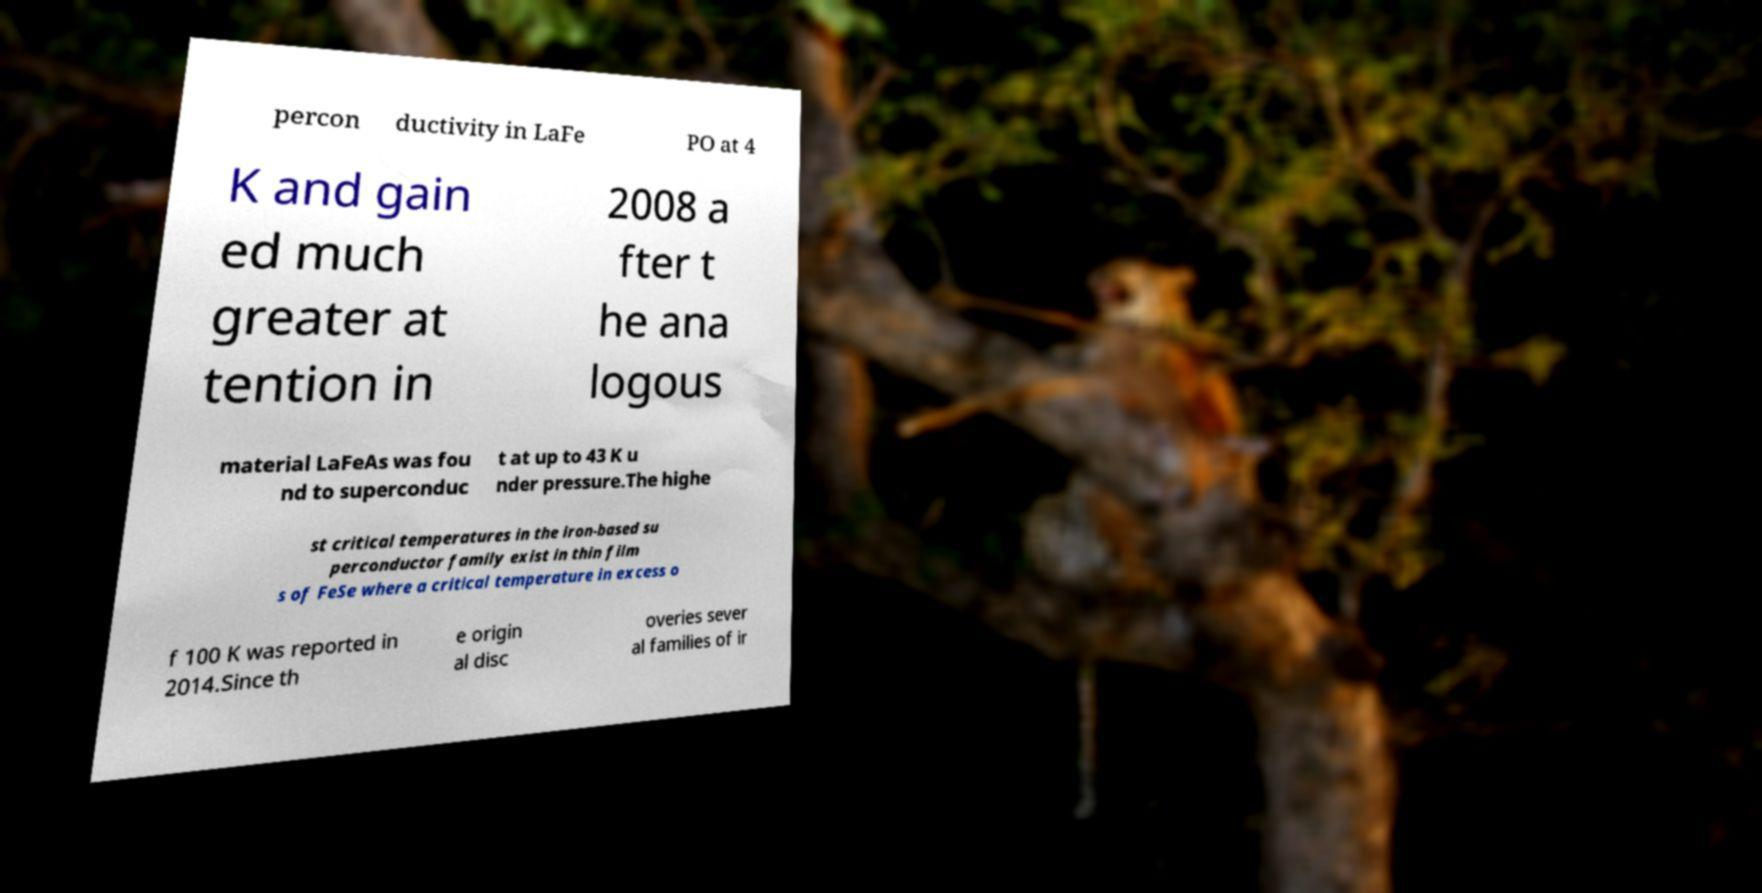Please read and relay the text visible in this image. What does it say? percon ductivity in LaFe PO at 4 K and gain ed much greater at tention in 2008 a fter t he ana logous material LaFeAs was fou nd to superconduc t at up to 43 K u nder pressure.The highe st critical temperatures in the iron-based su perconductor family exist in thin film s of FeSe where a critical temperature in excess o f 100 K was reported in 2014.Since th e origin al disc overies sever al families of ir 